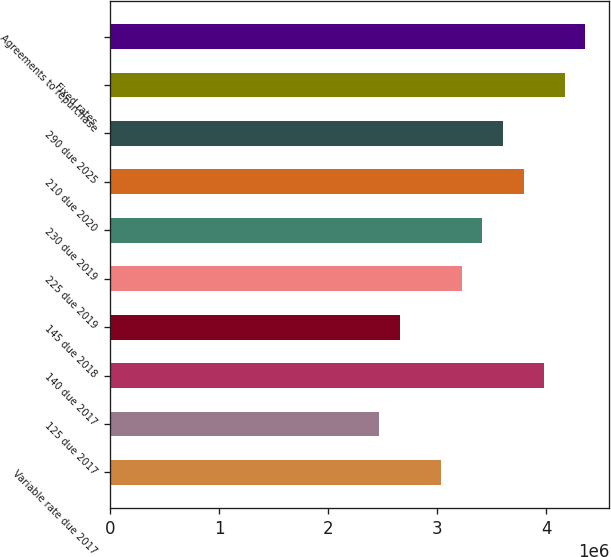Convert chart. <chart><loc_0><loc_0><loc_500><loc_500><bar_chart><fcel>Variable rate due 2017<fcel>125 due 2017<fcel>140 due 2017<fcel>145 due 2018<fcel>225 due 2019<fcel>230 due 2019<fcel>210 due 2020<fcel>290 due 2025<fcel>Fixed rates<fcel>Agreements to repurchase<nl><fcel>3.0349e+06<fcel>2.46709e+06<fcel>3.98125e+06<fcel>2.65636e+06<fcel>3.22417e+06<fcel>3.41344e+06<fcel>3.79198e+06<fcel>3.60271e+06<fcel>4.17052e+06<fcel>4.35979e+06<nl></chart> 